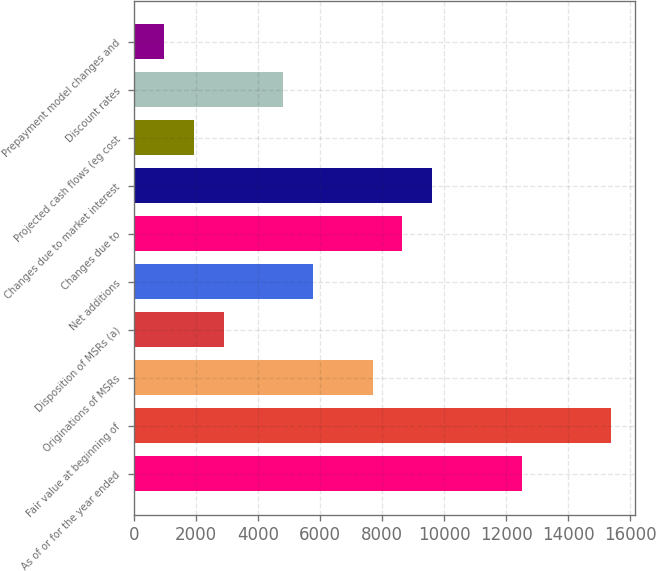Convert chart. <chart><loc_0><loc_0><loc_500><loc_500><bar_chart><fcel>As of or for the year ended<fcel>Fair value at beginning of<fcel>Originations of MSRs<fcel>Disposition of MSRs (a)<fcel>Net additions<fcel>Changes due to<fcel>Changes due to market interest<fcel>Projected cash flows (eg cost<fcel>Discount rates<fcel>Prepayment model changes and<nl><fcel>12495.6<fcel>15377.3<fcel>7692.9<fcel>2890.15<fcel>5771.8<fcel>8653.45<fcel>9614<fcel>1929.6<fcel>4811.25<fcel>969.05<nl></chart> 